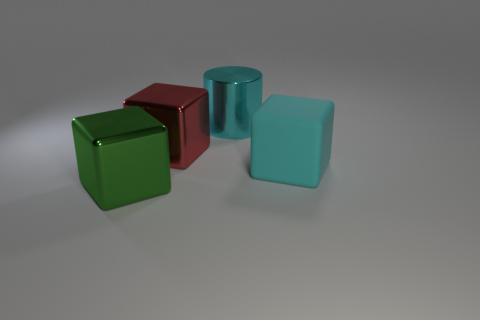What emotions might this arrangement of objects evoke? The clean lines, simple shapes, and calming colors might evoke a sense of order and tranquility. The minimalist arrangement allows viewers to appreciate the beauty in basic geometric forms and colors without any associated context. 